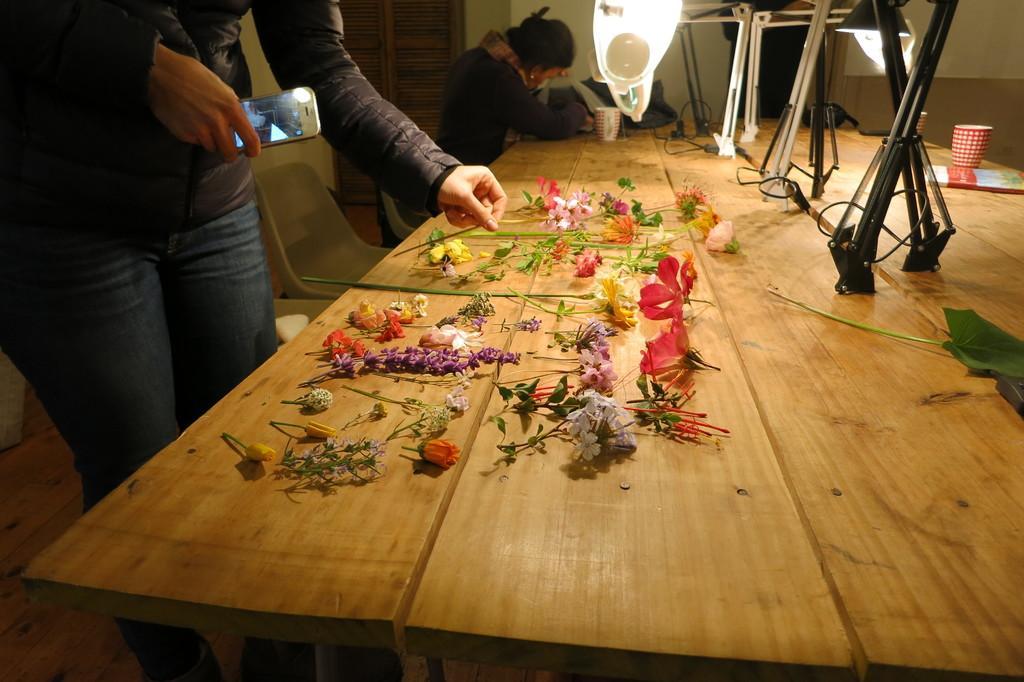How would you summarize this image in a sentence or two? On table we can see flowers,cup and light and stand and bedside table there are 2 persons and chairs. 